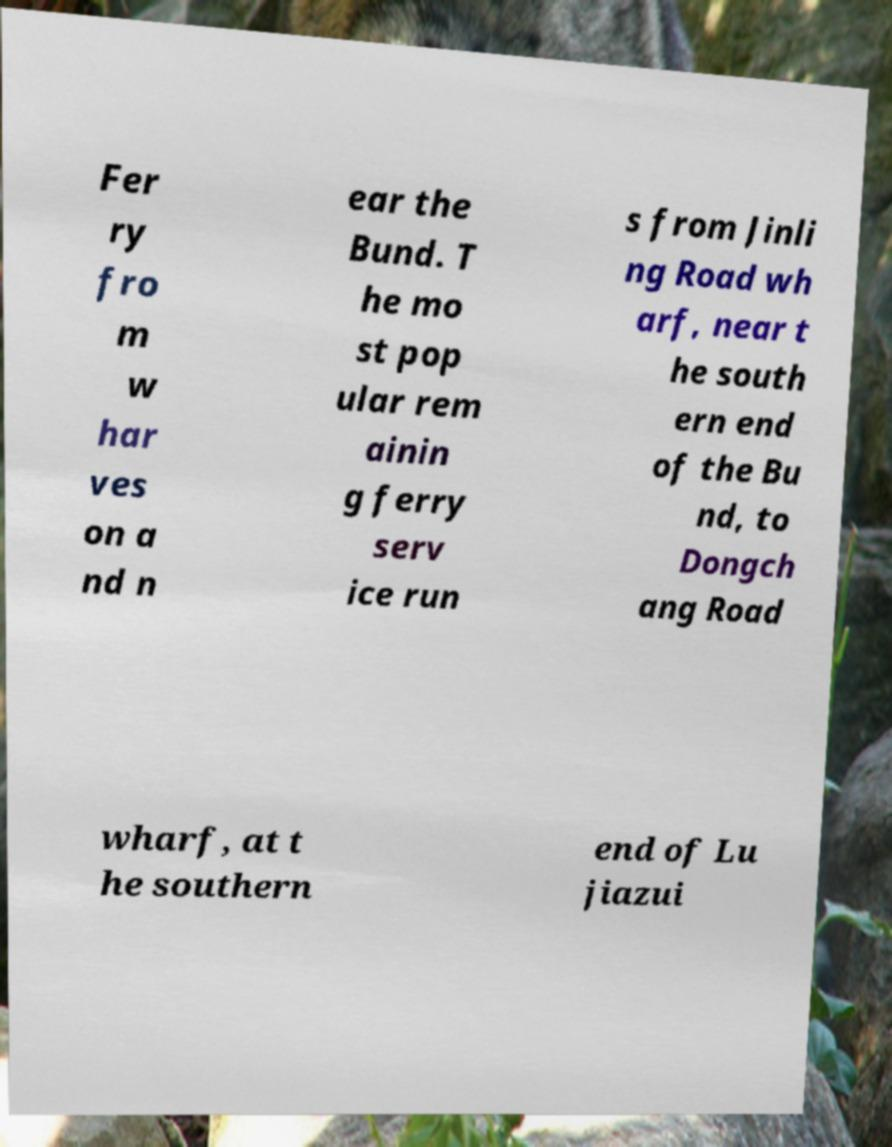Please identify and transcribe the text found in this image. Fer ry fro m w har ves on a nd n ear the Bund. T he mo st pop ular rem ainin g ferry serv ice run s from Jinli ng Road wh arf, near t he south ern end of the Bu nd, to Dongch ang Road wharf, at t he southern end of Lu jiazui 